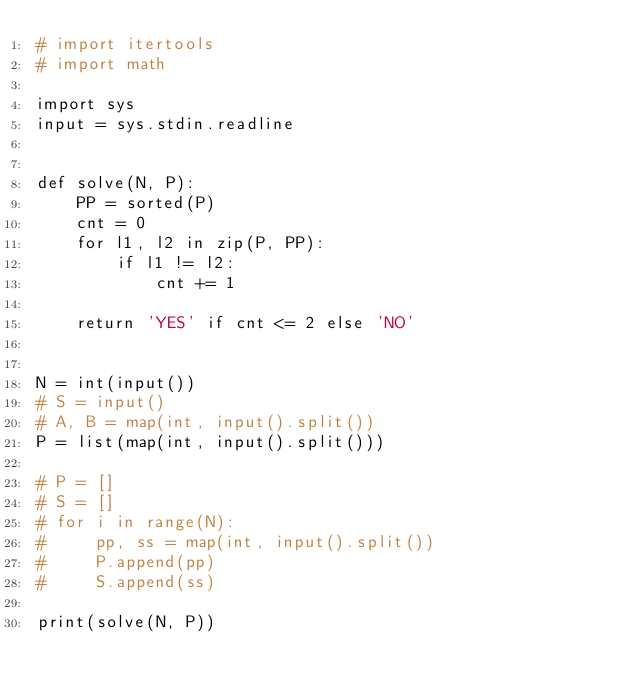<code> <loc_0><loc_0><loc_500><loc_500><_Python_># import itertools
# import math

import sys
input = sys.stdin.readline


def solve(N, P):
    PP = sorted(P)
    cnt = 0
    for l1, l2 in zip(P, PP):
        if l1 != l2:
            cnt += 1

    return 'YES' if cnt <= 2 else 'NO'


N = int(input())
# S = input()
# A, B = map(int, input().split())
P = list(map(int, input().split()))

# P = []
# S = []
# for i in range(N):
#     pp, ss = map(int, input().split())
#     P.append(pp)
#     S.append(ss)

print(solve(N, P))
</code> 